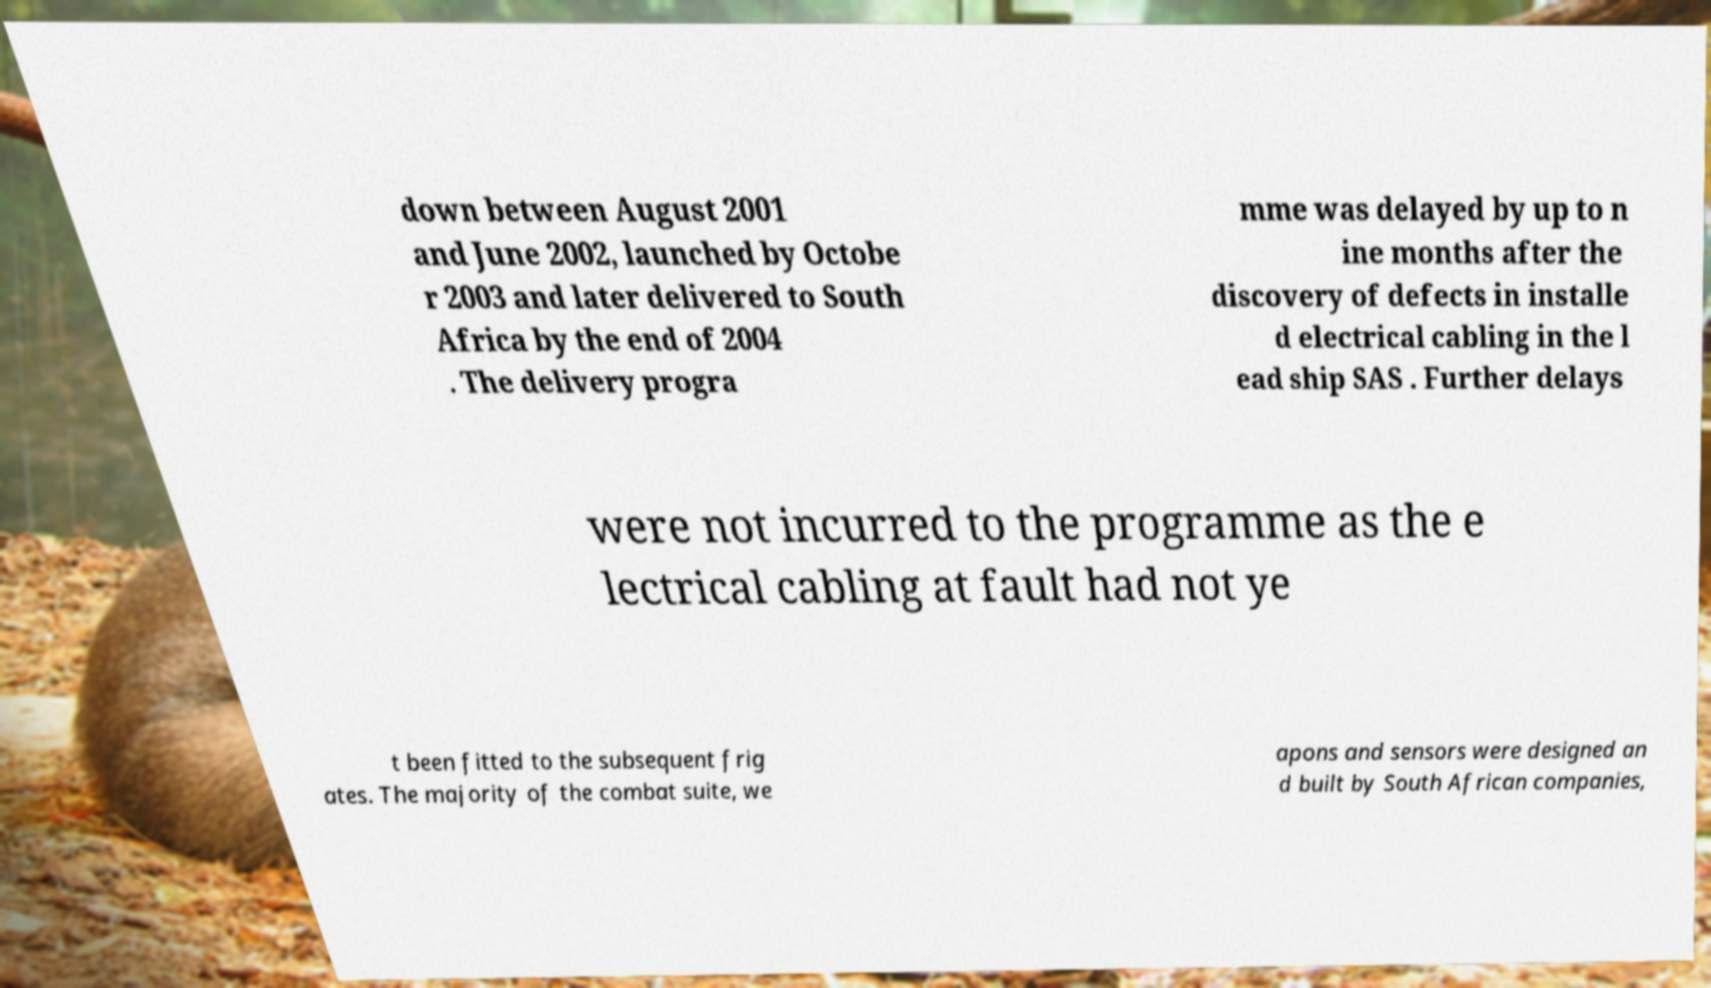Could you extract and type out the text from this image? down between August 2001 and June 2002, launched by Octobe r 2003 and later delivered to South Africa by the end of 2004 . The delivery progra mme was delayed by up to n ine months after the discovery of defects in installe d electrical cabling in the l ead ship SAS . Further delays were not incurred to the programme as the e lectrical cabling at fault had not ye t been fitted to the subsequent frig ates. The majority of the combat suite, we apons and sensors were designed an d built by South African companies, 